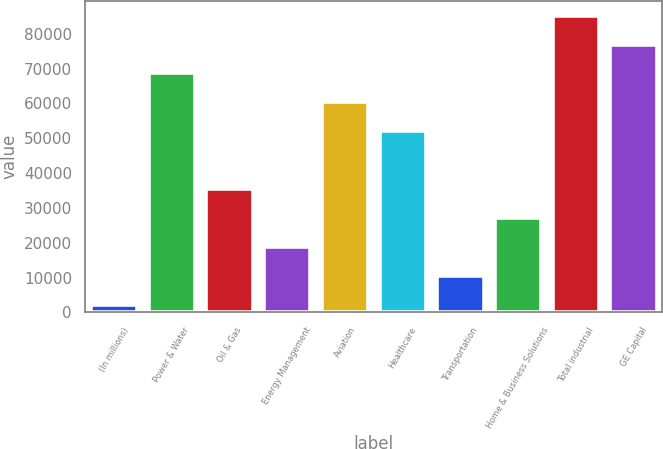Convert chart. <chart><loc_0><loc_0><loc_500><loc_500><bar_chart><fcel>(In millions)<fcel>Power & Water<fcel>Oil & Gas<fcel>Energy Management<fcel>Aviation<fcel>Healthcare<fcel>Transportation<fcel>Home & Business Solutions<fcel>Total industrial<fcel>GE Capital<nl><fcel>2010<fcel>68574.8<fcel>35292.4<fcel>18651.2<fcel>60254.2<fcel>51933.6<fcel>10330.6<fcel>26971.8<fcel>85216<fcel>76895.4<nl></chart> 